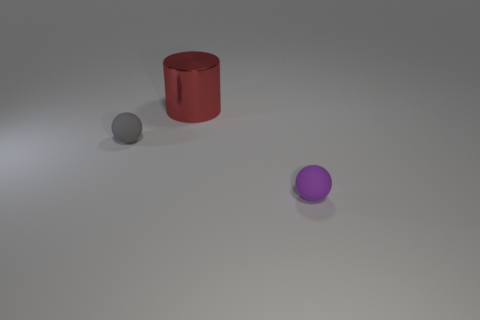Add 2 large cylinders. How many objects exist? 5 Subtract all cylinders. How many objects are left? 2 Subtract all tiny brown matte cylinders. Subtract all small gray matte spheres. How many objects are left? 2 Add 3 small gray things. How many small gray things are left? 4 Add 2 tiny gray matte spheres. How many tiny gray matte spheres exist? 3 Subtract 0 cyan cylinders. How many objects are left? 3 